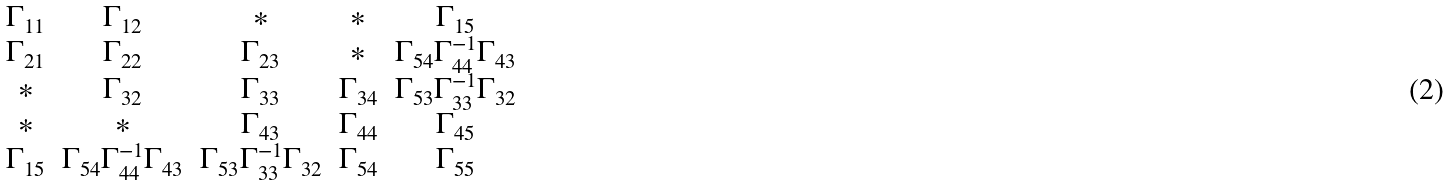<formula> <loc_0><loc_0><loc_500><loc_500>\begin{matrix} \Gamma _ { 1 1 } & \Gamma _ { 1 2 } & * & * & \Gamma _ { 1 5 } \\ \Gamma _ { 2 1 } & \Gamma _ { 2 2 } & \Gamma _ { 2 3 } & * & \Gamma _ { 5 4 } \Gamma _ { 4 4 } ^ { - 1 } \Gamma _ { 4 3 } \\ * & \Gamma _ { 3 2 } & \Gamma _ { 3 3 } & \Gamma _ { 3 4 } & \Gamma _ { 5 3 } \Gamma _ { 3 3 } ^ { - 1 } \Gamma _ { 3 2 } \\ * & * & \Gamma _ { 4 3 } & \Gamma _ { 4 4 } & \Gamma _ { 4 5 } \\ \Gamma _ { 1 5 } & \Gamma _ { 5 4 } \Gamma _ { 4 4 } ^ { - 1 } \Gamma _ { 4 3 } & \Gamma _ { 5 3 } \Gamma _ { 3 3 } ^ { - 1 } \Gamma _ { 3 2 } & \Gamma _ { 5 4 } & \Gamma _ { 5 5 } \end{matrix}</formula> 